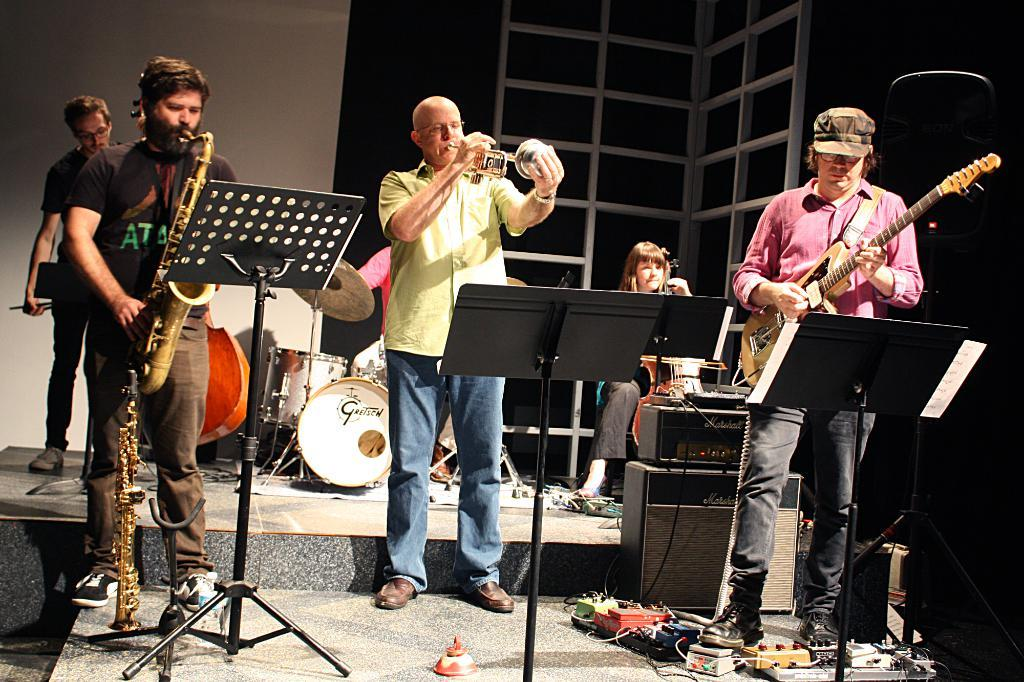What are the people in the image doing? The people in the image are holding musical instruments. Can you describe the background of the image? There are musical instruments and a wall in the background of the image. What type of advertisement can be seen on the wall in the image? There is no advertisement visible on the wall in the image. What is the time of day depicted in the image? The provided facts do not give any information about the time of day, so it cannot be determined from the image. 